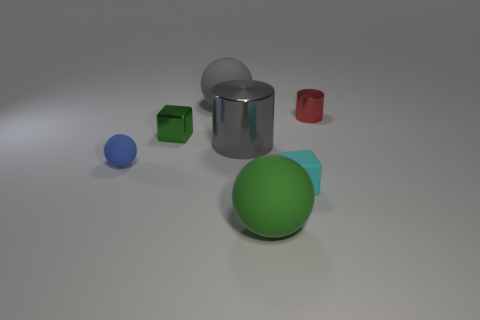Subtract all small blue balls. How many balls are left? 2 Add 1 rubber balls. How many objects exist? 8 Subtract all green balls. How many balls are left? 2 Subtract 1 blocks. How many blocks are left? 1 Subtract 0 brown blocks. How many objects are left? 7 Subtract all blocks. How many objects are left? 5 Subtract all cyan blocks. Subtract all gray cylinders. How many blocks are left? 1 Subtract all gray metal blocks. Subtract all green matte things. How many objects are left? 6 Add 2 metal cylinders. How many metal cylinders are left? 4 Add 4 large brown things. How many large brown things exist? 4 